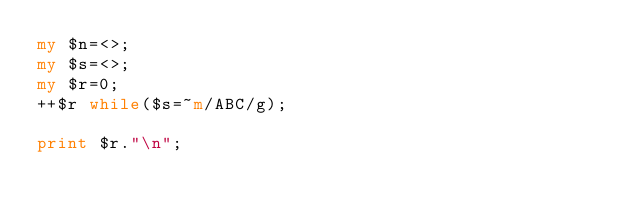<code> <loc_0><loc_0><loc_500><loc_500><_Perl_>my $n=<>;
my $s=<>;
my $r=0;
++$r while($s=~m/ABC/g);

print $r."\n";
</code> 